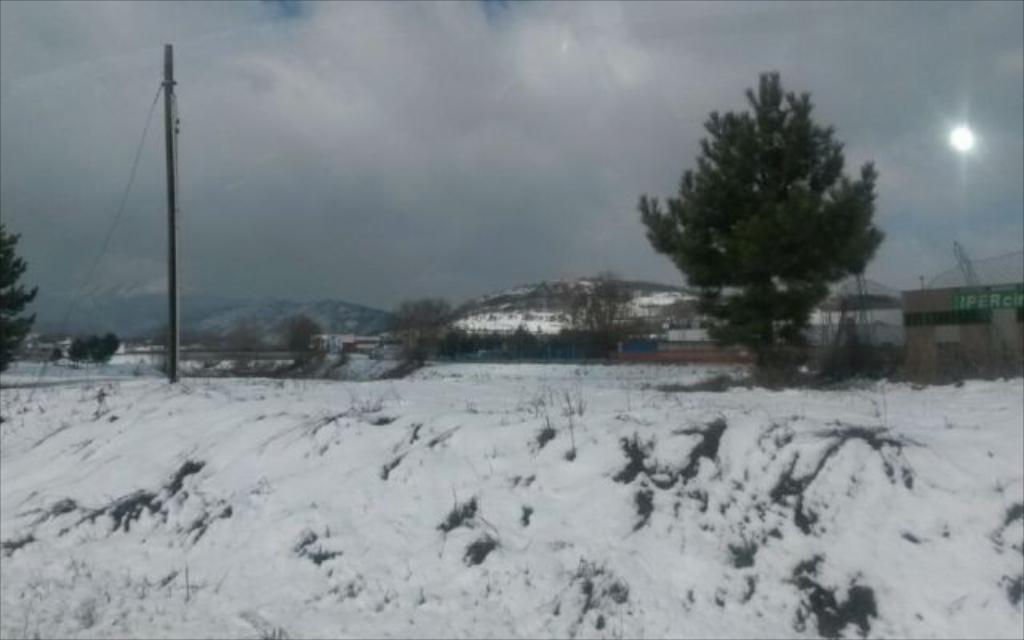Please provide a concise description of this image. At the bottom there is the snow, in the middle there are trees. At the top it is the cloudy sky. 